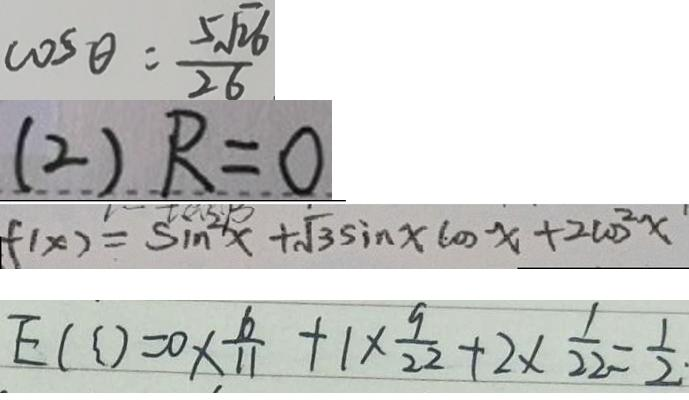<formula> <loc_0><loc_0><loc_500><loc_500>\cos \theta = \frac { 5 \sqrt { 2 6 } } { 2 6 } 
 ( 2 ) R = 0 
 f ( x ) = \sin ^ { 2 } x + \sqrt { 3 } \sin x \cos x + 2 \cos ^ { 2 } x 
 E ( \zeta ) = 0 \times \frac { 6 } { 1 1 } + 1 \times \frac { 9 } { 2 2 } + 2 \times \frac { 1 } { 2 2 } = \frac { 1 } { 2 }</formula> 